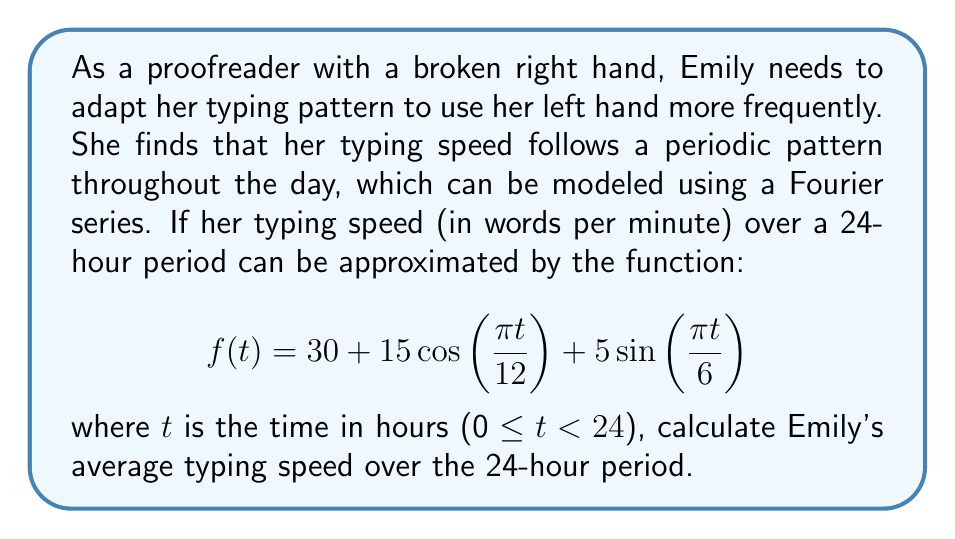Could you help me with this problem? To solve this problem, we need to understand that the average value of a periodic function over its period is equal to the constant term (a₀) in its Fourier series representation. In this case, the function is already given in the form of a Fourier series:

$$f(t) = 30 + 15\cos\left(\frac{\pi t}{12}\right) + 5\sin\left(\frac{\pi t}{6}\right)$$

Let's break down the components:

1. The constant term: $a_0 = 30$
2. Cosine term: $15\cos\left(\frac{\pi t}{12}\right)$
3. Sine term: $5\sin\left(\frac{\pi t}{6}\right)$

The average value of both the cosine and sine terms over their full period is zero. Therefore, the average value of the function $f(t)$ over the 24-hour period is simply the constant term, which is 30.

To verify this mathematically, we can calculate the average using the integral formula:

$$\text{Average} = \frac{1}{T}\int_0^T f(t) dt$$

Where T is the period (24 hours in this case):

$$\begin{align*}
\text{Average} &= \frac{1}{24}\int_0^{24} \left(30 + 15\cos\left(\frac{\pi t}{12}\right) + 5\sin\left(\frac{\pi t}{6}\right)\right) dt \\
&= \frac{1}{24}\left[30t + \frac{180}{\pi}\sin\left(\frac{\pi t}{12}\right) - \frac{60}{\pi}\cos\left(\frac{\pi t}{6}\right)\right]_0^{24} \\
&= \frac{1}{24}(720 + 0 - 0) \\
&= 30
\end{align*}$$

This confirms that the average typing speed is indeed 30 words per minute.
Answer: Emily's average typing speed over the 24-hour period is 30 words per minute. 